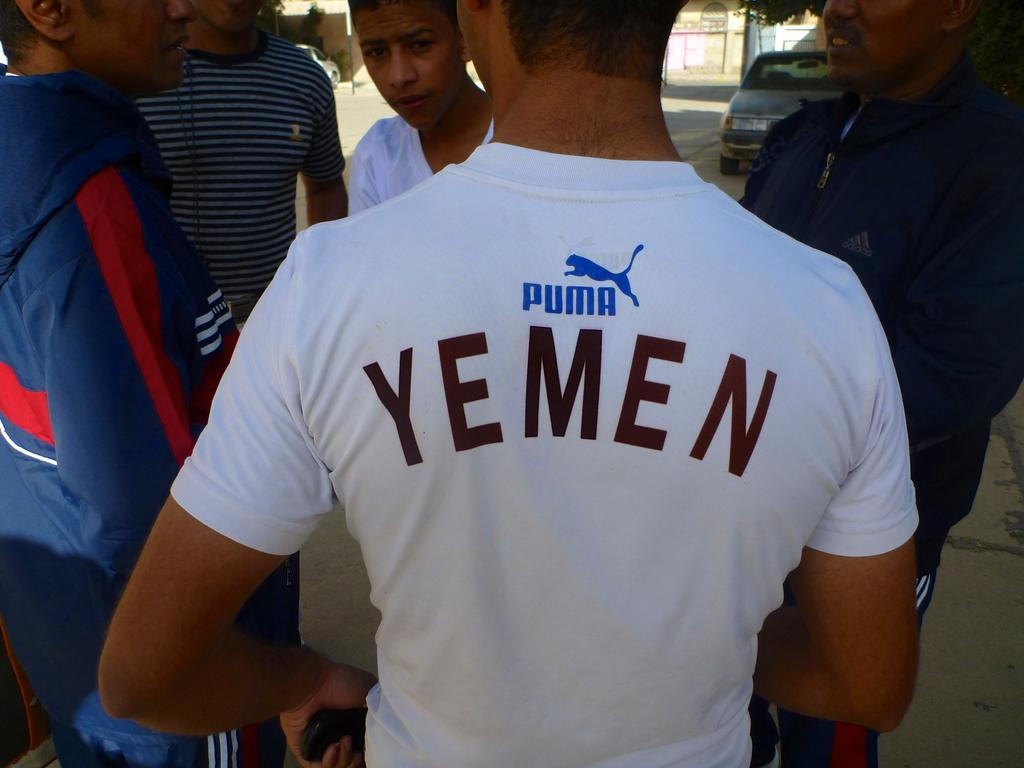<image>
Write a terse but informative summary of the picture. The young man's white t-shirt proudly displayed, "Yemen". 